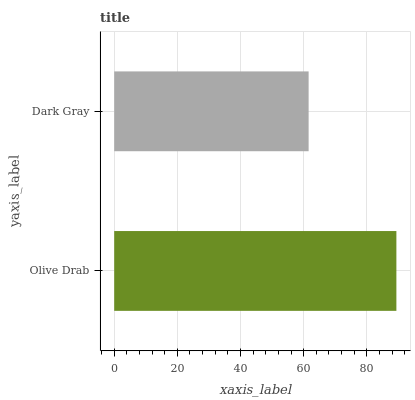Is Dark Gray the minimum?
Answer yes or no. Yes. Is Olive Drab the maximum?
Answer yes or no. Yes. Is Dark Gray the maximum?
Answer yes or no. No. Is Olive Drab greater than Dark Gray?
Answer yes or no. Yes. Is Dark Gray less than Olive Drab?
Answer yes or no. Yes. Is Dark Gray greater than Olive Drab?
Answer yes or no. No. Is Olive Drab less than Dark Gray?
Answer yes or no. No. Is Olive Drab the high median?
Answer yes or no. Yes. Is Dark Gray the low median?
Answer yes or no. Yes. Is Dark Gray the high median?
Answer yes or no. No. Is Olive Drab the low median?
Answer yes or no. No. 